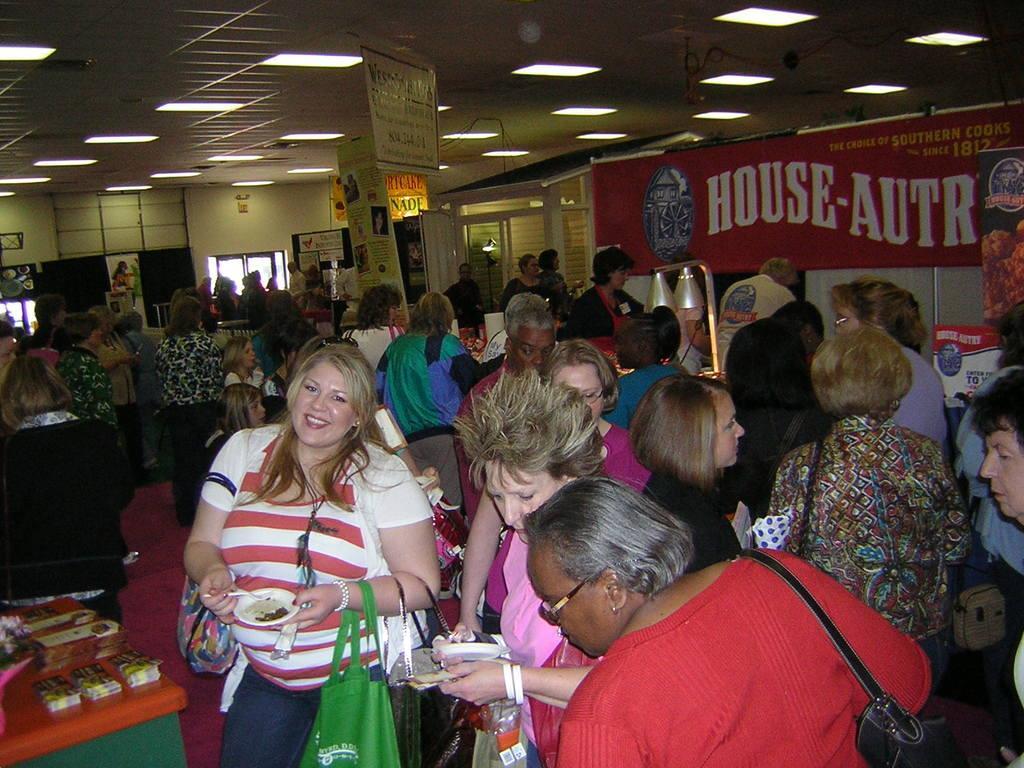Can you describe this image briefly? In this picture we can see some people standing, a woman in the front is holding a spoon and a cup, she is carrying three bags, on the left side there is a table, we can see some things present on the table, on the right side there is a hoarding, we can see some boards in the background, there are some lights at the top of the picture, in the background there is a wall. 